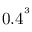<formula> <loc_0><loc_0><loc_500><loc_500>0 . 4 ^ { ^ { 3 } }</formula> 